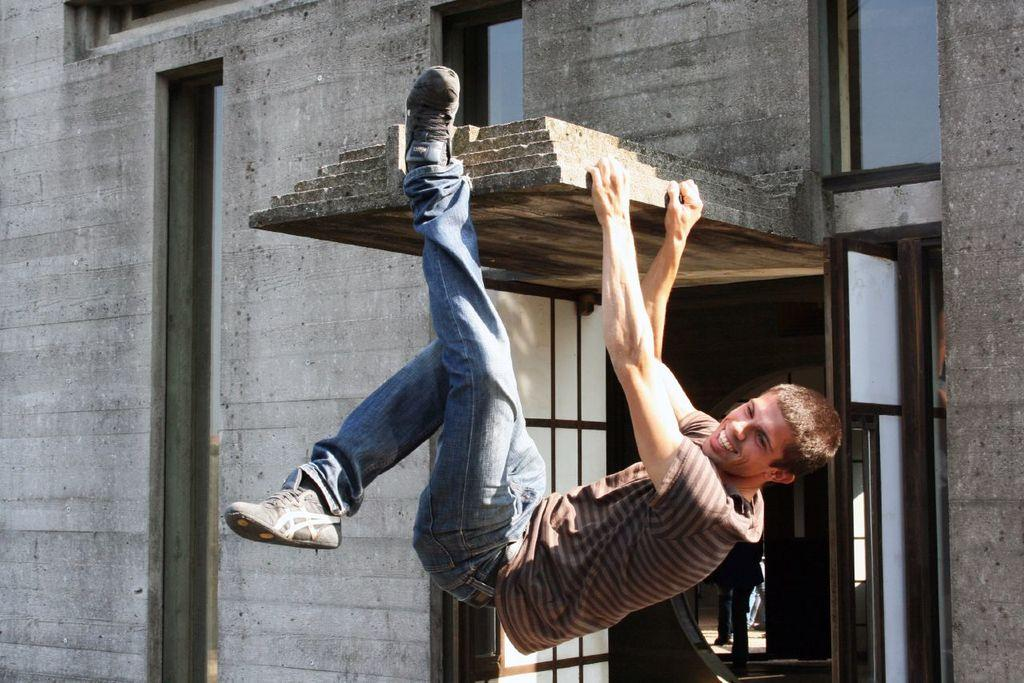What is the person in the image doing? The person is hanging with their hands on a building. What can be seen on the building in the image? There are windows visible on the building. How many sisters does the person in the image have? There is no information about the person's sisters in the image, so we cannot determine the number of sisters they have. What color is the person's eye in the image? The image does not show the person's eye, so we cannot determine the color of their eye. 